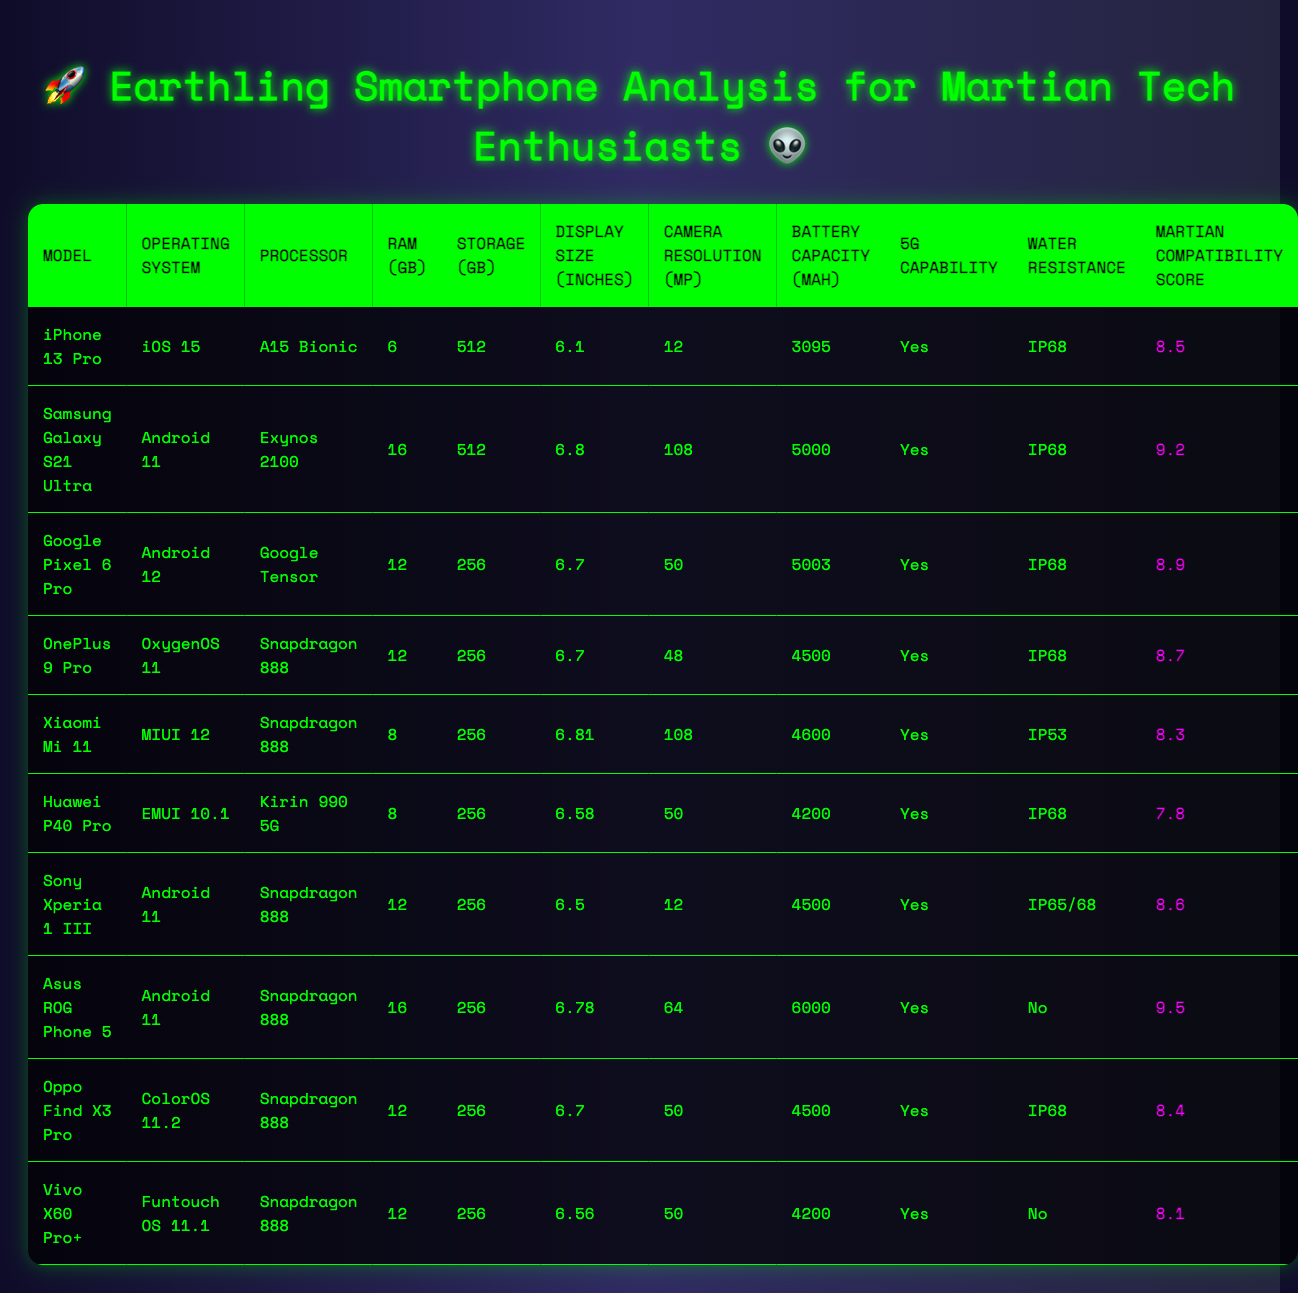What is the battery capacity of the Samsung Galaxy S21 Ultra? The battery capacity of the Samsung Galaxy S21 Ultra can be found in the table under "Battery Capacity (mAh)" alongside its model name. It shows a value of 5000 mAh.
Answer: 5000 mAh Which smartphone has the highest Martian Compatibility Score? To find the highest Martian Compatibility Score, I look at the "Martian Compatibility Score" column and identify that the Asus ROG Phone 5 has the highest score of 9.5.
Answer: 9.5 What is the average RAM of the smartphones listed? I total the RAM values: 6 + 16 + 12 + 12 + 8 + 8 + 12 + 16 + 12 + 12 = 102. There are 10 models, so the average RAM is 102/10 = 10.2 GB.
Answer: 10.2 GB Do any of the smartphones have a display size larger than 6.8 inches? I compare the "Display Size (inches)" column to find that the Samsung Galaxy S21 Ultra has a display size of 6.8 inches, but no models exceed this size. Therefore, the answer is no.
Answer: No Which smartphone has the least water resistance rating, and what is it? By examining the "Water Resistance" column, the Xiaomi Mi 11 has the least rating of "IP53," while others have higher ratings like IP68.
Answer: Xiaomi Mi 11, IP53 Is there a smartphone that does not have 5G capability? I review the "5G Capability" column and find that all smartphones listed have the value 'Yes' indicating they all support 5G. Therefore, the answer is no.
Answer: No How many smartphones have a camera resolution of 50 MP or higher? I count the entries in the "Camera Resolution (MP)" column that are 50 MP or more: Google Pixel 6 Pro (50 MP), OnePlus 9 Pro (48 MP, not counted), Xiaomi Mi 11 (108 MP), Huawei P40 Pro (50 MP), Sony Xperia 1 III (12 MP, not counted), Asus ROG Phone 5 (64 MP), Oppo Find X3 Pro (50 MP), and Vivo X60 Pro+ (50 MP). This gives a total of 5 smartphones.
Answer: 5 What is the difference in battery capacity between the iPhone 13 Pro and the Asus ROG Phone 5? The battery capacity of the iPhone 13 Pro is 3095 mAh, and for the Asus ROG Phone 5, it is 6000 mAh. I subtract these values: 6000 - 3095 = 2905 mAh.
Answer: 2905 mAh Which model has the most RAM and what is its value? I check the "RAM (GB)" column and observe that the Samsung Galaxy S21 Ultra and Asus ROG Phone 5 have the highest RAM value at 16 GB.
Answer: Samsung Galaxy S21 Ultra, 16 GB How many smartphones are listed with a Martian Compatibility Score above 8.5? I review the "Martian Compatibility Score" values and identify that the models with scores above 8.5 are Samsung Galaxy S21 Ultra (9.2), Google Pixel 6 Pro (8.9), Asus ROG Phone 5 (9.5). Thus, there are 3 such smartphones.
Answer: 3 What is the combined storage of the top three smartphones by storage capacity? The top three smartphones by storage capacity are iPhone 13 Pro (512 GB), Samsung Galaxy S21 Ultra (512 GB), and Google Pixel 6 Pro (256 GB). I add these values: 512 + 512 + 256 = 1280 GB.
Answer: 1280 GB 